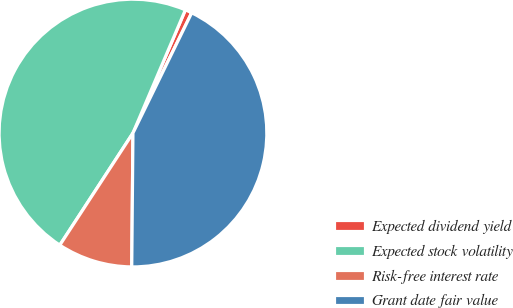Convert chart to OTSL. <chart><loc_0><loc_0><loc_500><loc_500><pie_chart><fcel>Expected dividend yield<fcel>Expected stock volatility<fcel>Risk-free interest rate<fcel>Grant date fair value<nl><fcel>0.83%<fcel>47.2%<fcel>9.06%<fcel>42.91%<nl></chart> 